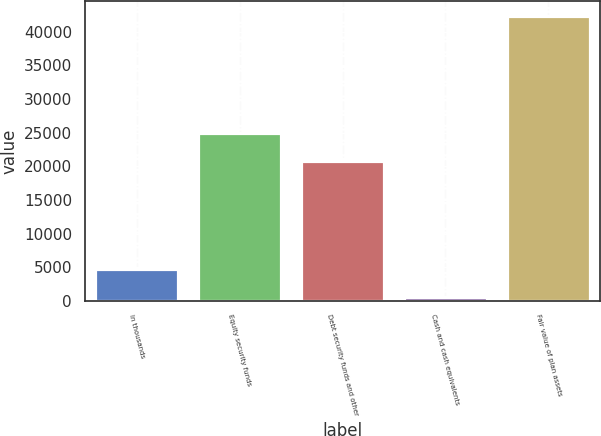Convert chart. <chart><loc_0><loc_0><loc_500><loc_500><bar_chart><fcel>In thousands<fcel>Equity security funds<fcel>Debt security funds and other<fcel>Cash and cash equivalents<fcel>Fair value of plan assets<nl><fcel>4723.6<fcel>24971.6<fcel>20785<fcel>537<fcel>42403<nl></chart> 